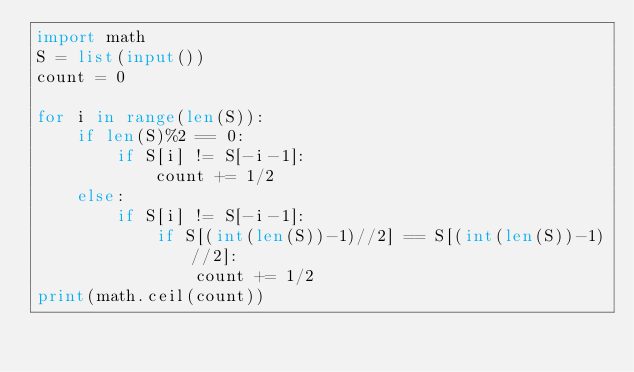Convert code to text. <code><loc_0><loc_0><loc_500><loc_500><_Python_>import math
S = list(input())
count = 0

for i in range(len(S)):
    if len(S)%2 == 0:
        if S[i] != S[-i-1]:
            count += 1/2
    else:
        if S[i] != S[-i-1]:
            if S[(int(len(S))-1)//2] == S[(int(len(S))-1)//2]:
                count += 1/2
print(math.ceil(count))
</code> 